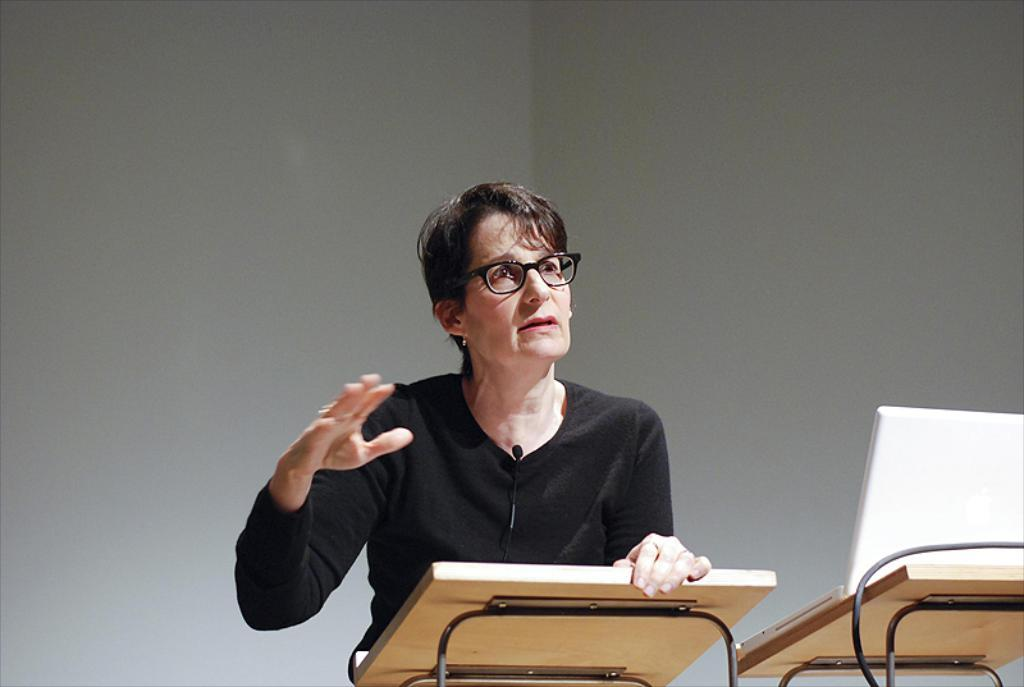Who is the main subject in the image? There is a woman in the image. What is the woman doing in the image? The woman is speaking. What is the woman wearing on her upper body? The woman is wearing a black top. Does the woman have any accessories in the image? Yes, the woman is wearing spectacles. What type of veil is the woman wearing in the image? There is no veil present in the image; the woman is wearing spectacles. Can you describe the zipper on the woman's top in the image? There is no zipper on the woman's top in the image; she is wearing a black top. 